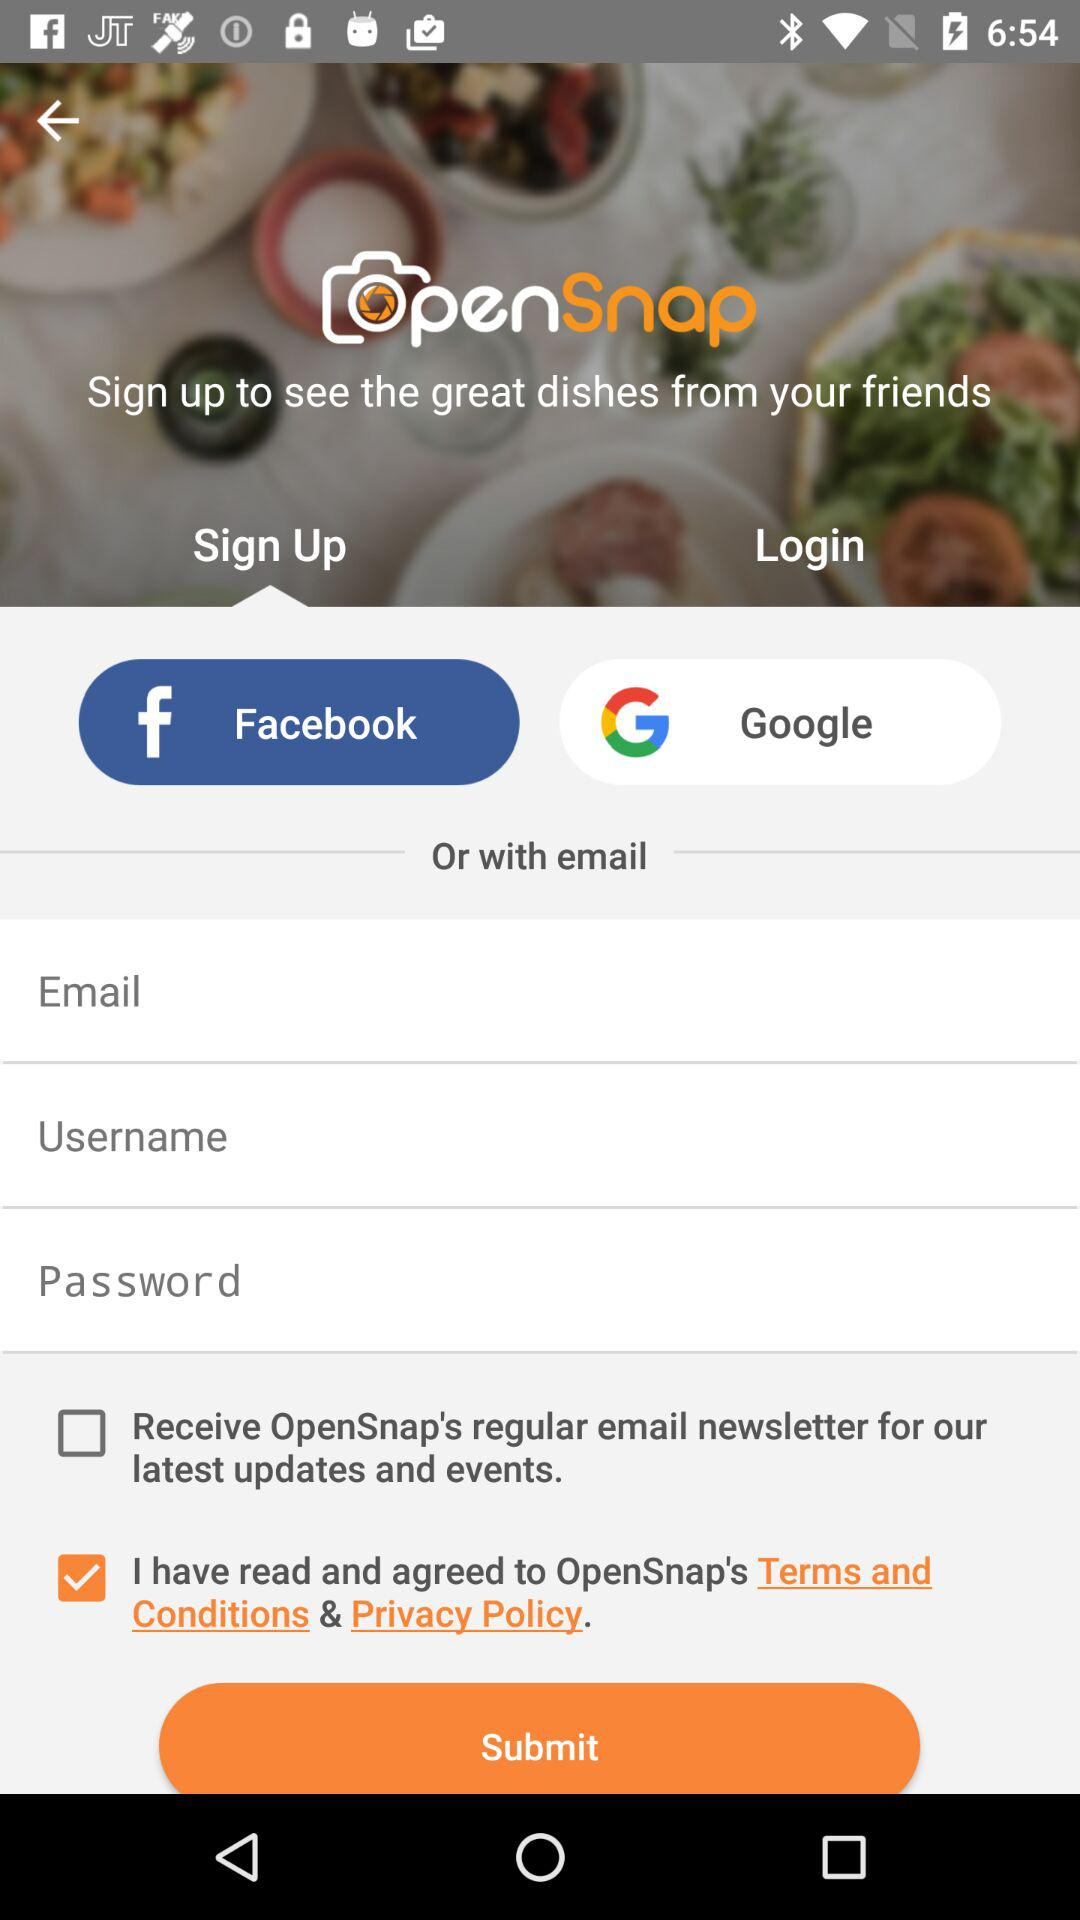What is the application name? The application name is "OpenSnap". 